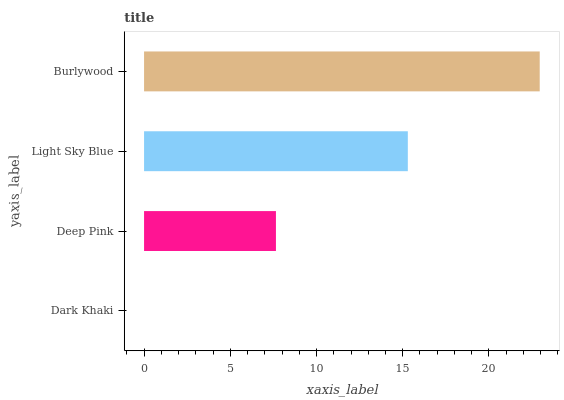Is Dark Khaki the minimum?
Answer yes or no. Yes. Is Burlywood the maximum?
Answer yes or no. Yes. Is Deep Pink the minimum?
Answer yes or no. No. Is Deep Pink the maximum?
Answer yes or no. No. Is Deep Pink greater than Dark Khaki?
Answer yes or no. Yes. Is Dark Khaki less than Deep Pink?
Answer yes or no. Yes. Is Dark Khaki greater than Deep Pink?
Answer yes or no. No. Is Deep Pink less than Dark Khaki?
Answer yes or no. No. Is Light Sky Blue the high median?
Answer yes or no. Yes. Is Deep Pink the low median?
Answer yes or no. Yes. Is Deep Pink the high median?
Answer yes or no. No. Is Dark Khaki the low median?
Answer yes or no. No. 